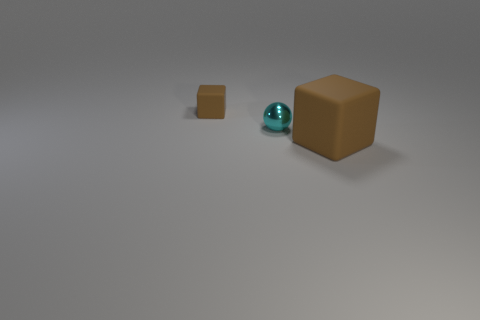Add 3 large cyan balls. How many objects exist? 6 Subtract all cubes. How many objects are left? 1 Subtract all small cyan metal objects. Subtract all rubber objects. How many objects are left? 0 Add 2 large brown matte objects. How many large brown matte objects are left? 3 Add 1 small metallic balls. How many small metallic balls exist? 2 Subtract 0 cyan cubes. How many objects are left? 3 